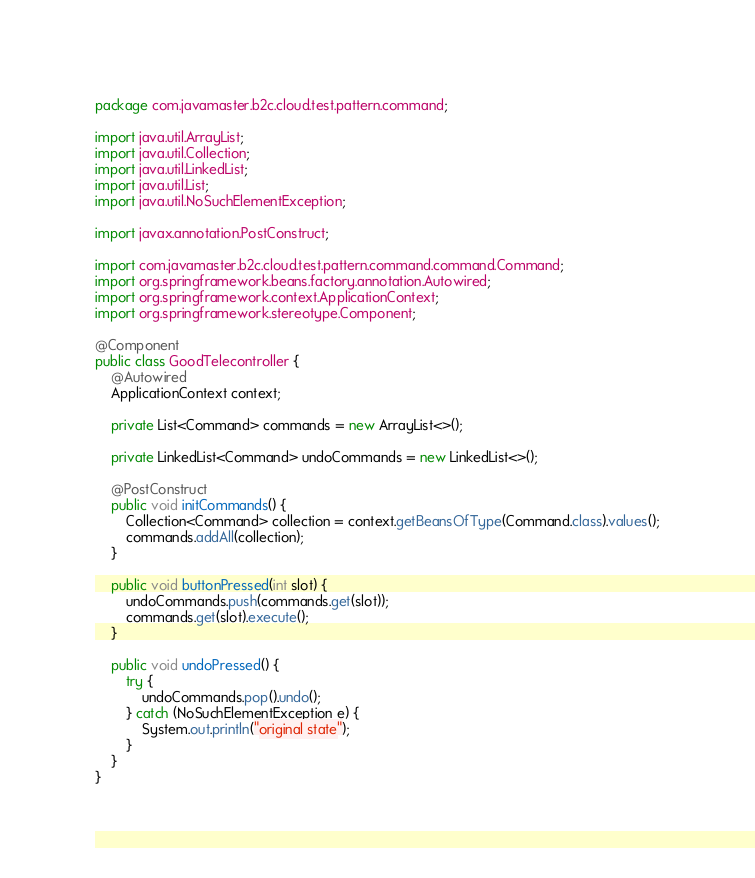<code> <loc_0><loc_0><loc_500><loc_500><_Java_>package com.javamaster.b2c.cloud.test.pattern.command;

import java.util.ArrayList;
import java.util.Collection;
import java.util.LinkedList;
import java.util.List;
import java.util.NoSuchElementException;

import javax.annotation.PostConstruct;

import com.javamaster.b2c.cloud.test.pattern.command.command.Command;
import org.springframework.beans.factory.annotation.Autowired;
import org.springframework.context.ApplicationContext;
import org.springframework.stereotype.Component;

@Component
public class GoodTelecontroller {
	@Autowired
	ApplicationContext context;

	private List<Command> commands = new ArrayList<>();

	private LinkedList<Command> undoCommands = new LinkedList<>();

	@PostConstruct
	public void initCommands() {
		Collection<Command> collection = context.getBeansOfType(Command.class).values();
		commands.addAll(collection);
	}

	public void buttonPressed(int slot) {
		undoCommands.push(commands.get(slot));
		commands.get(slot).execute();
	}

	public void undoPressed() {
		try {
			undoCommands.pop().undo();
		} catch (NoSuchElementException e) {
			System.out.println("original state");
		}
	}
}
</code> 